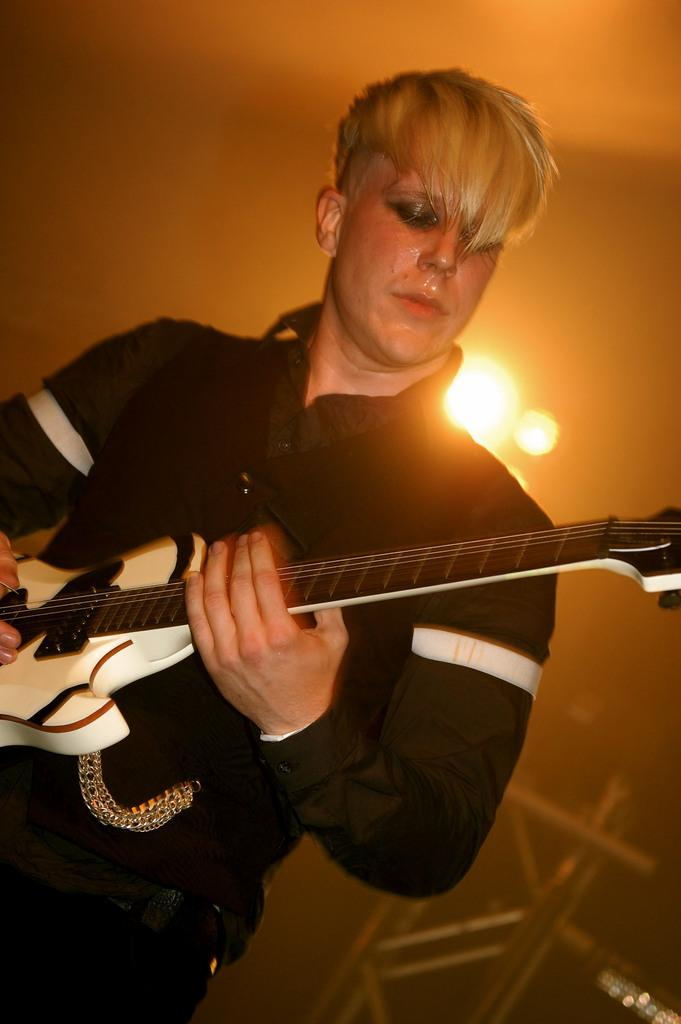What is the person in the image doing? The person in the image is playing a guitar. How is the person positioned in the image? The person is standing. What is visible in the background of the image? There is a wall visible in the image. What can be seen illuminating the scene in the image? There are lights visible in the image. What type of blade is being used by the person in the image? There is no blade present in the image; the person is playing a guitar. What type of art can be seen on the wall in the image? There is no art visible on the wall in the image; only the wall itself is present. 